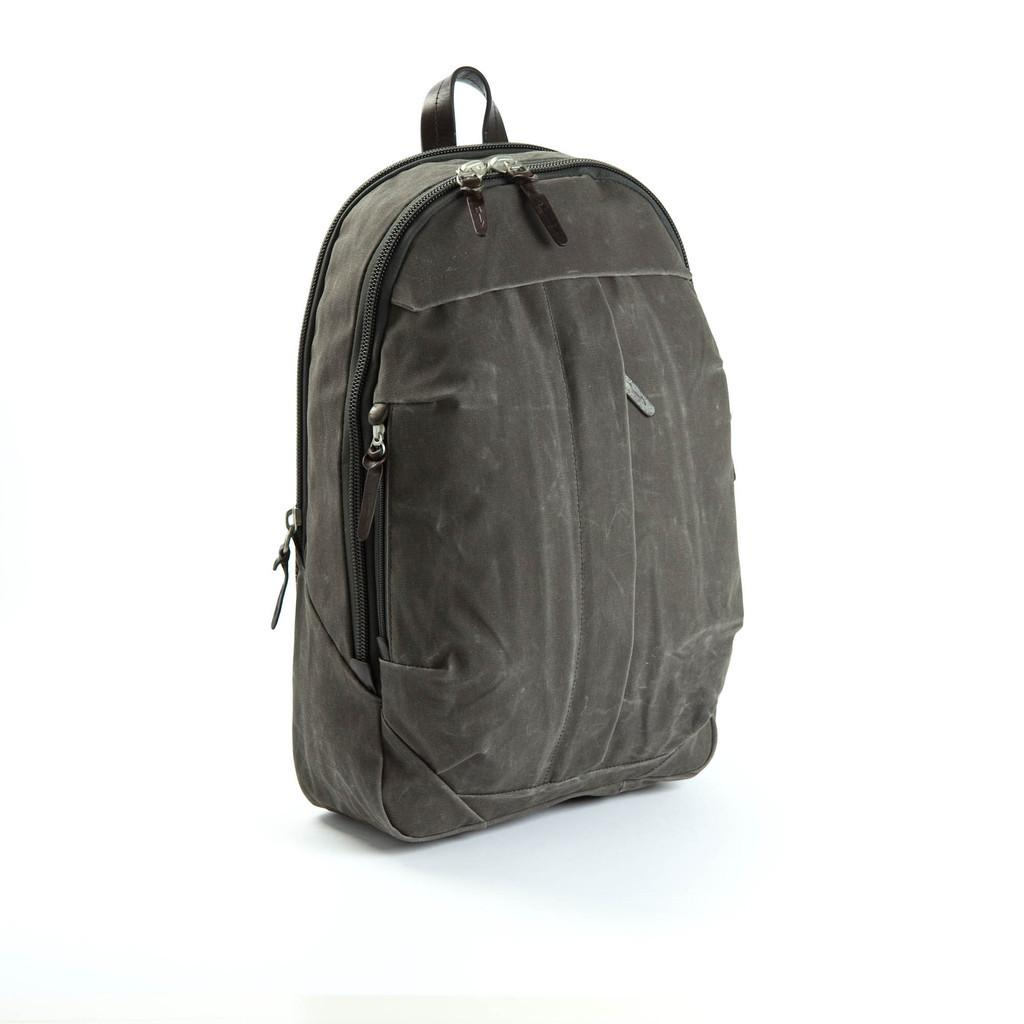What object can be seen in the image? There is a backpack in the image. What is the color of the backpack? The backpack is black in color. How many cows are visible in the image? There are no cows present in the image; it features a black backpack. What is the limit of the backpack's capacity in the image? The image does not provide information about the backpack's capacity, so it cannot be determined. 